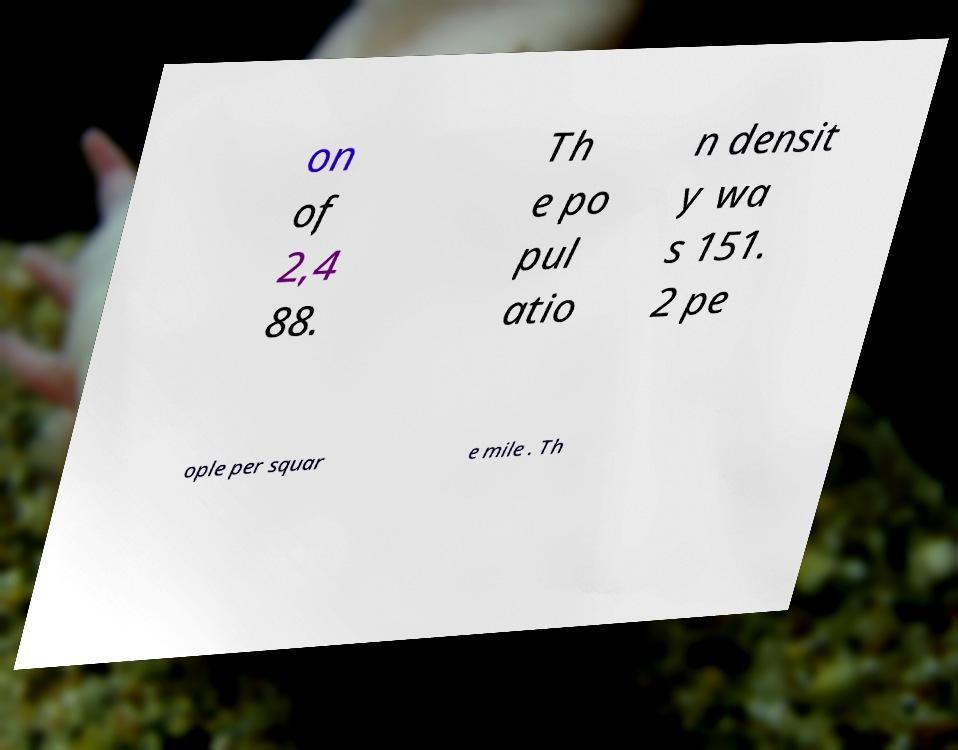Can you accurately transcribe the text from the provided image for me? on of 2,4 88. Th e po pul atio n densit y wa s 151. 2 pe ople per squar e mile . Th 